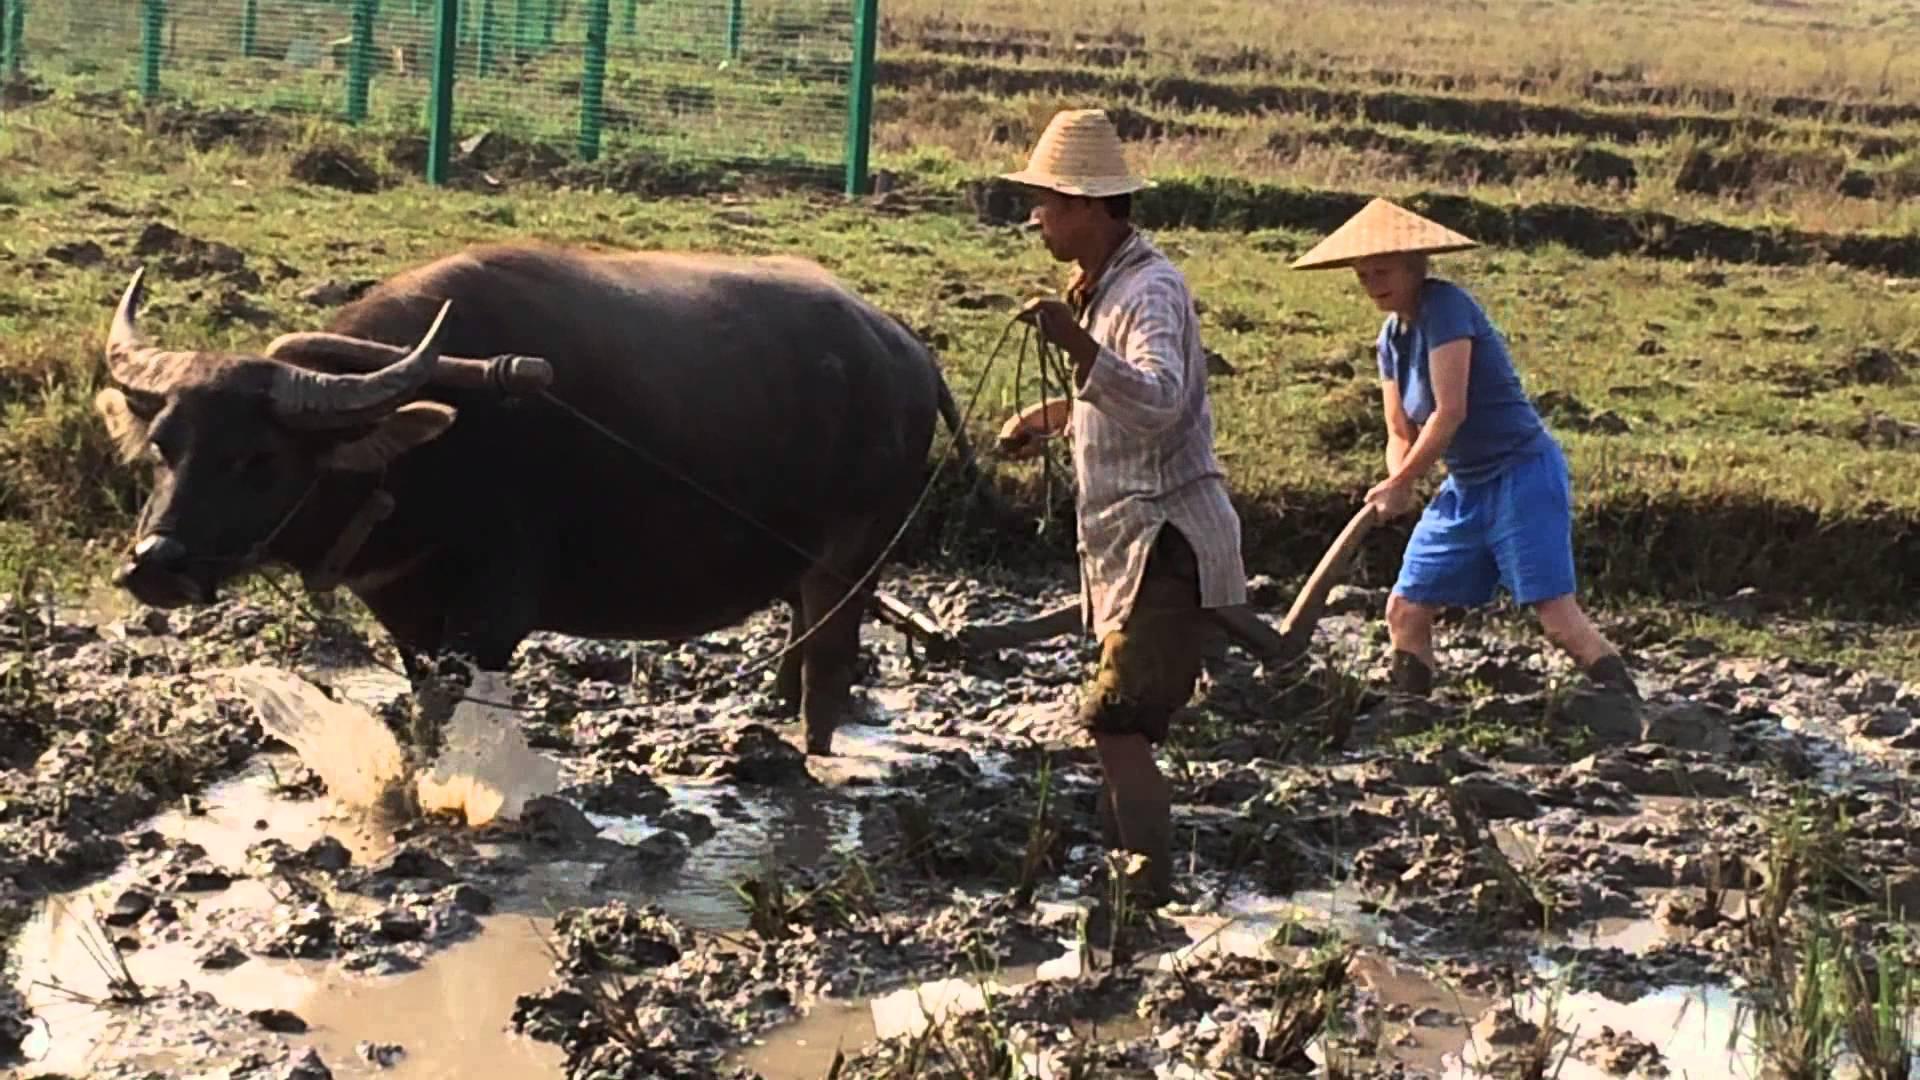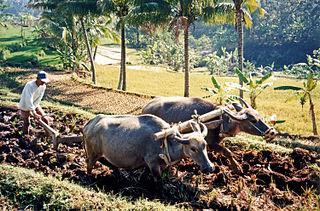The first image is the image on the left, the second image is the image on the right. Analyze the images presented: Is the assertion "There are two horned ox pulling a til held by a man with a white long sleeve shirt and ball cap." valid? Answer yes or no. Yes. 